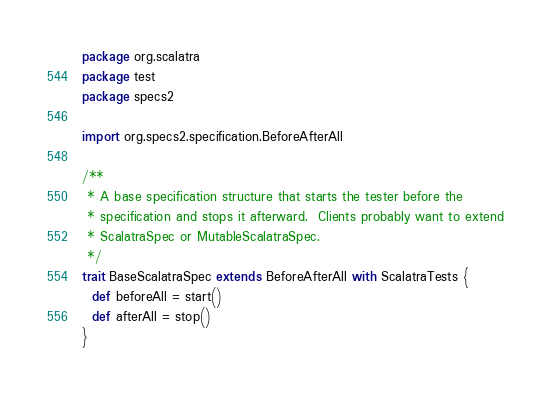<code> <loc_0><loc_0><loc_500><loc_500><_Scala_>package org.scalatra
package test
package specs2

import org.specs2.specification.BeforeAfterAll

/**
 * A base specification structure that starts the tester before the
 * specification and stops it afterward.  Clients probably want to extend
 * ScalatraSpec or MutableScalatraSpec.
 */
trait BaseScalatraSpec extends BeforeAfterAll with ScalatraTests {
  def beforeAll = start()
  def afterAll = stop()
}
</code> 